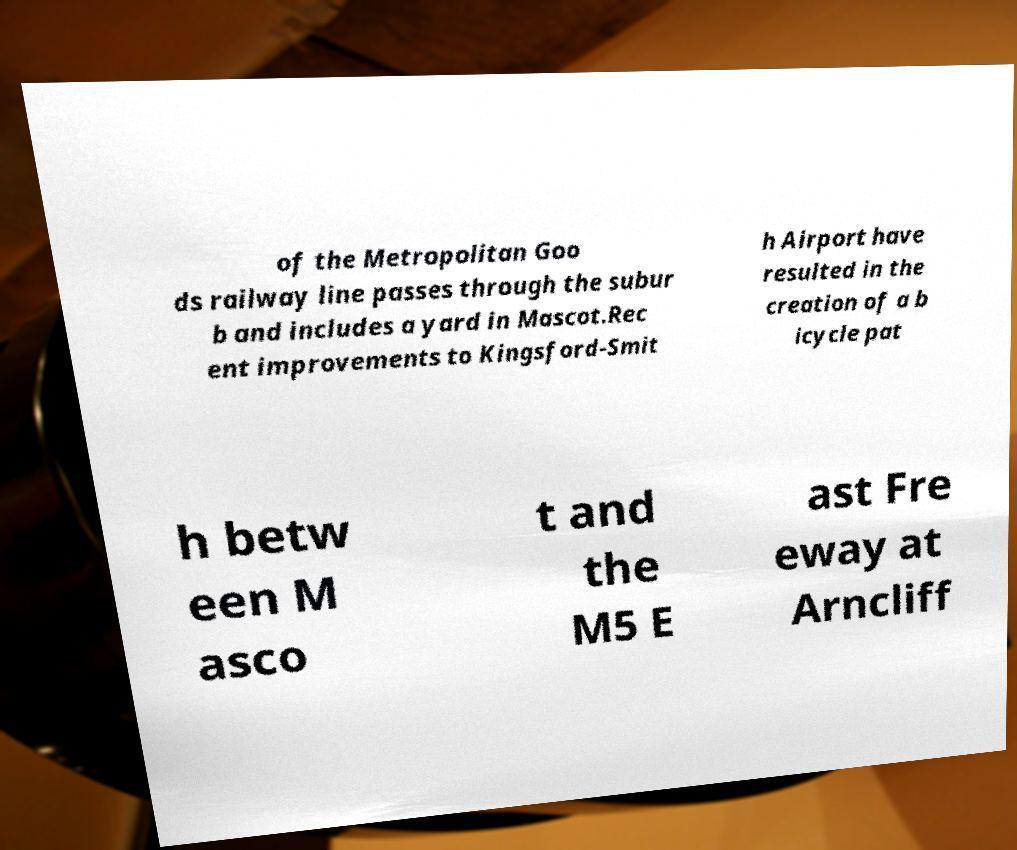Could you extract and type out the text from this image? of the Metropolitan Goo ds railway line passes through the subur b and includes a yard in Mascot.Rec ent improvements to Kingsford-Smit h Airport have resulted in the creation of a b icycle pat h betw een M asco t and the M5 E ast Fre eway at Arncliff 